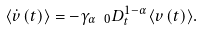Convert formula to latex. <formula><loc_0><loc_0><loc_500><loc_500>\langle \dot { v } \left ( t \right ) \rangle = - \gamma _ { \alpha } \ _ { 0 } D ^ { 1 - \alpha } _ { t } \langle v \left ( t \right ) \rangle .</formula> 